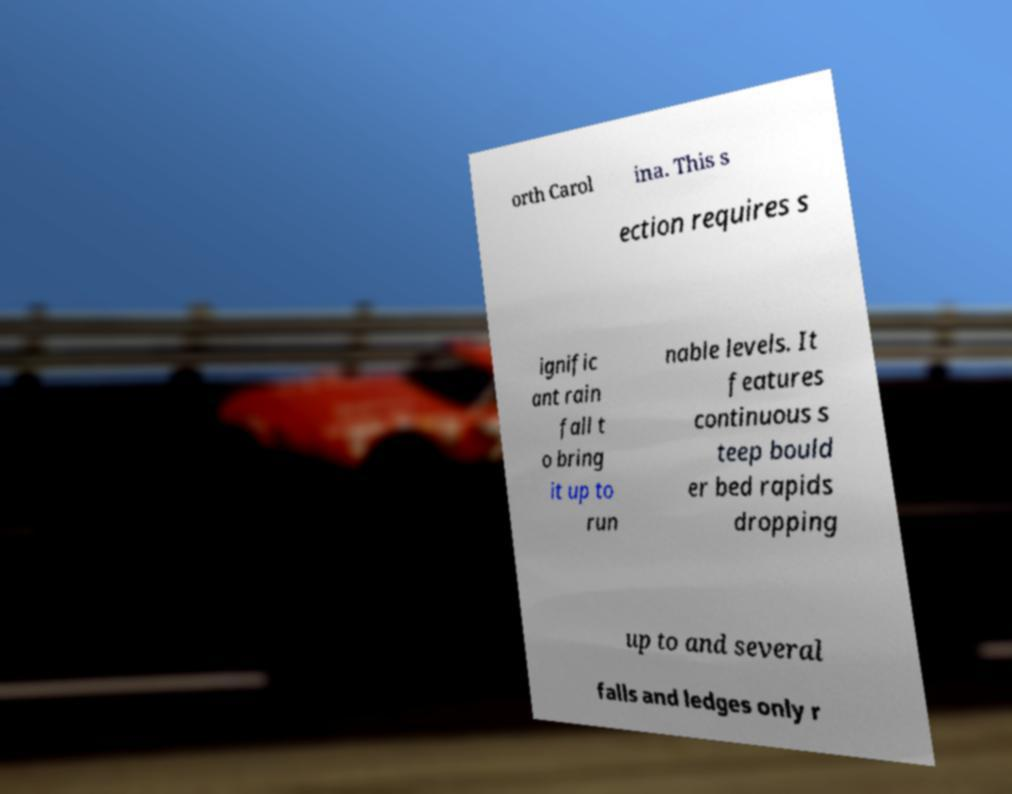What messages or text are displayed in this image? I need them in a readable, typed format. orth Carol ina. This s ection requires s ignific ant rain fall t o bring it up to run nable levels. It features continuous s teep bould er bed rapids dropping up to and several falls and ledges only r 